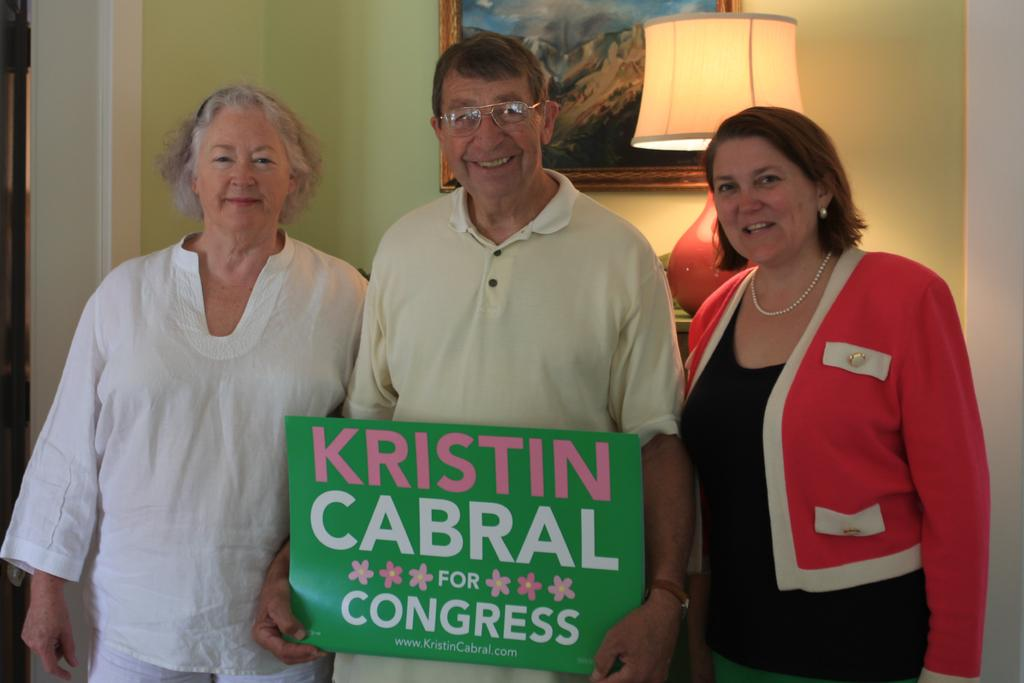How many people are in the image? There are three people in the image. What can be observed about the clothing of the people in the image? The people are wearing different color dresses. What is one person doing in the image? One person is holding a board. What objects can be seen in the background of the image? There is a lamp and a frame on the wall in the background of the image. What type of holiday is being celebrated in the image? There is no indication of a holiday being celebrated in the image. Are the three people in the image sisters? The relationship between the people in the image is not mentioned, so we cannot determine if they are sisters. 